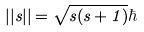<formula> <loc_0><loc_0><loc_500><loc_500>| | s | | = \sqrt { s ( s + 1 ) } \hbar</formula> 